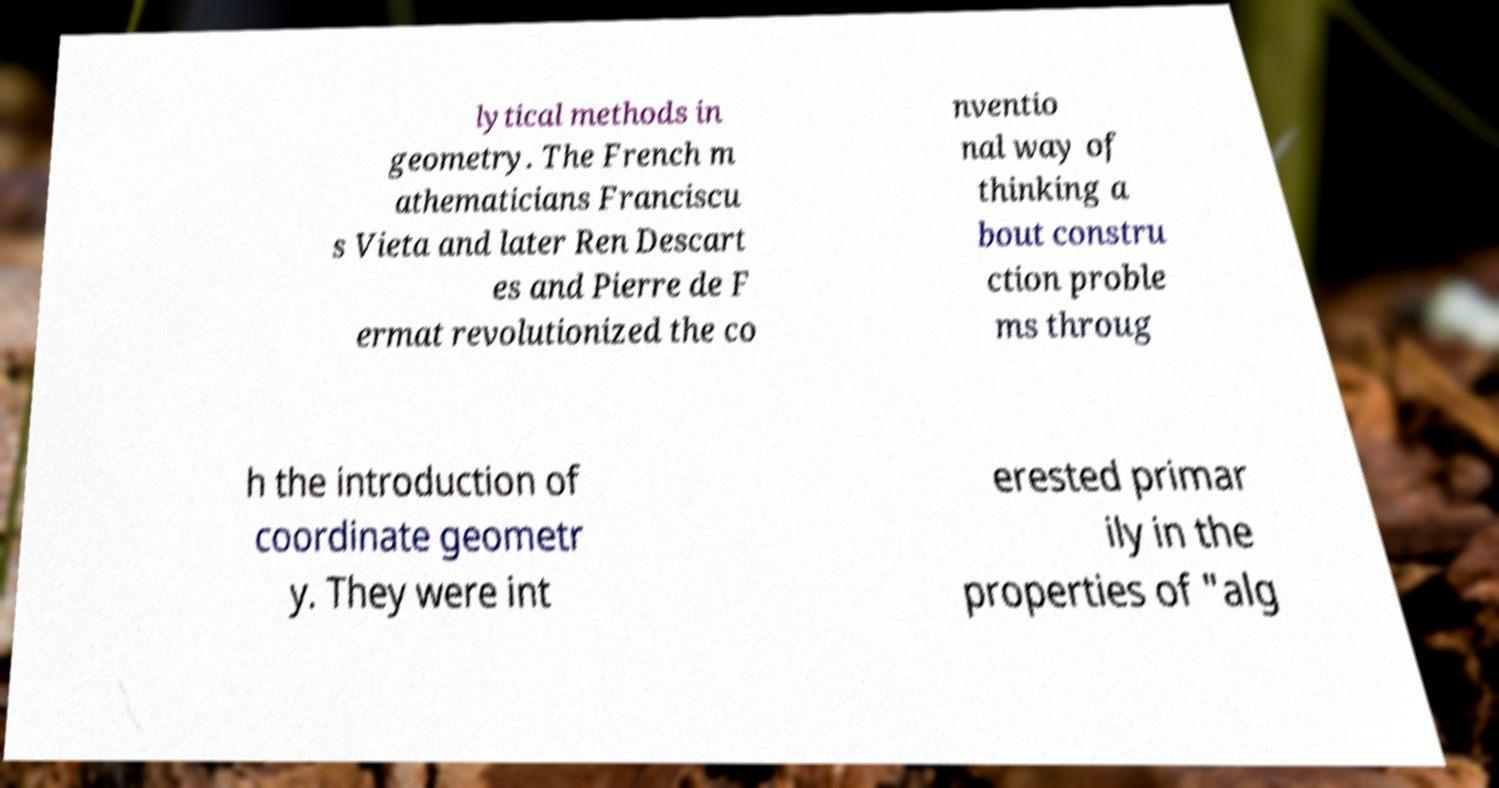For documentation purposes, I need the text within this image transcribed. Could you provide that? lytical methods in geometry. The French m athematicians Franciscu s Vieta and later Ren Descart es and Pierre de F ermat revolutionized the co nventio nal way of thinking a bout constru ction proble ms throug h the introduction of coordinate geometr y. They were int erested primar ily in the properties of "alg 